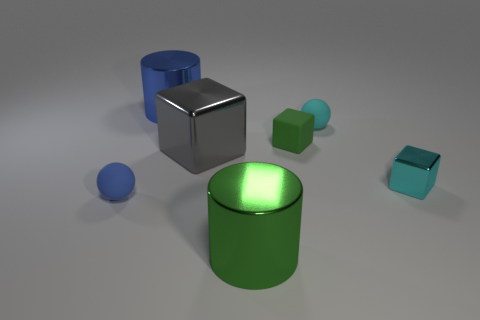Are these objects placed randomly, or is there a specific arrangement? The objects appear to be arranged intentionally, with varying sizes and colors to demonstrate a contrast in scale and hue, likely for artistic or illustrative purposes. 